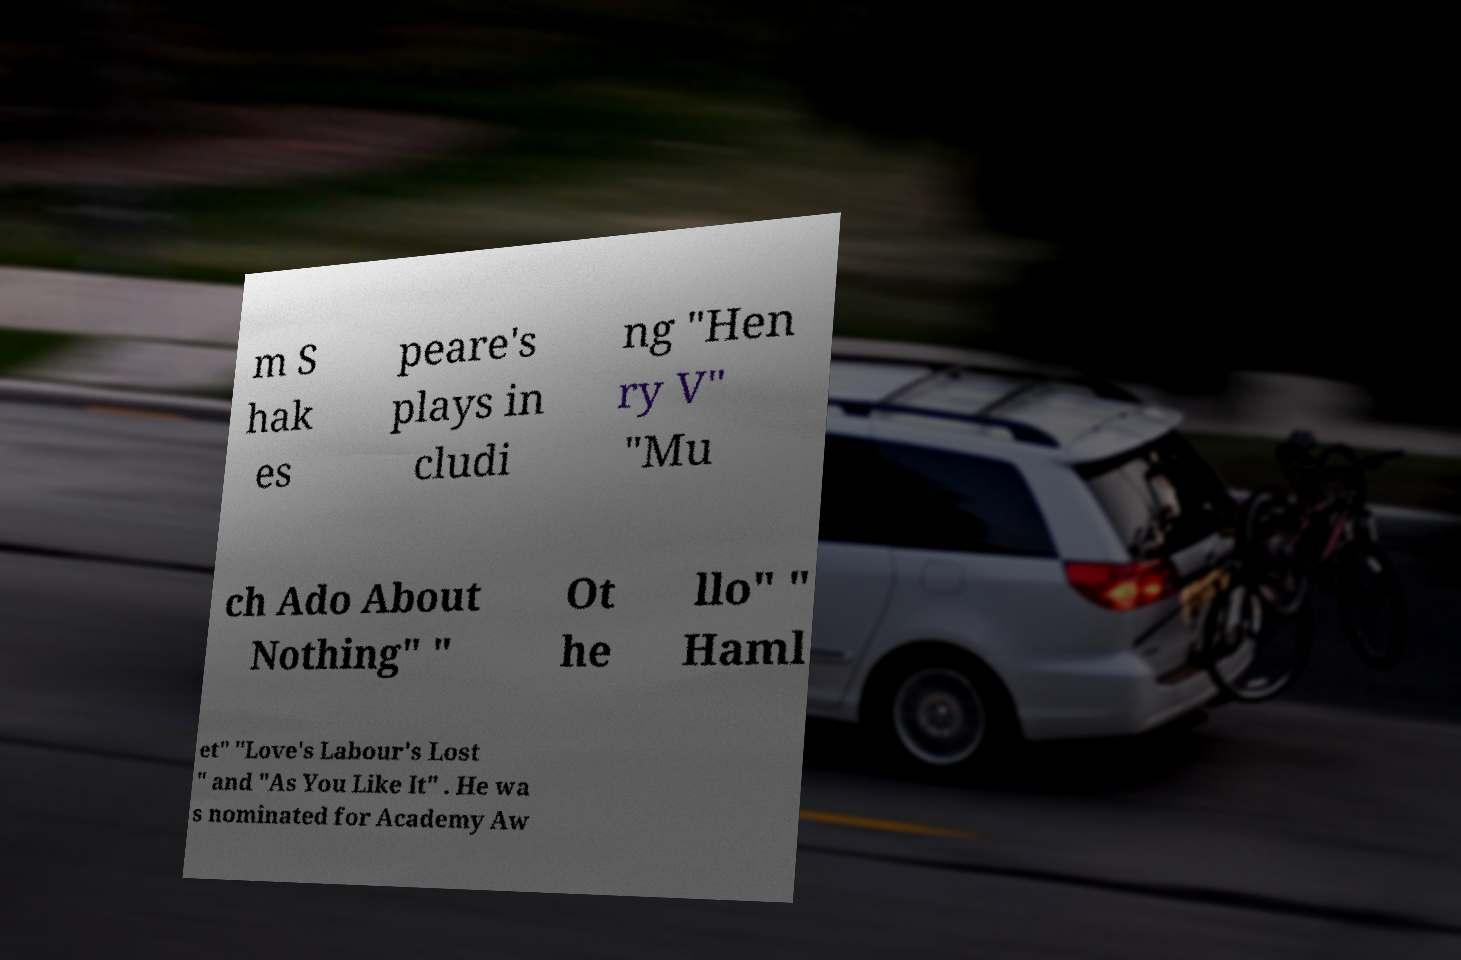Could you extract and type out the text from this image? m S hak es peare's plays in cludi ng "Hen ry V" "Mu ch Ado About Nothing" " Ot he llo" " Haml et" "Love's Labour's Lost " and "As You Like It" . He wa s nominated for Academy Aw 